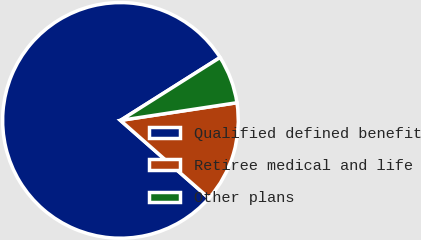Convert chart to OTSL. <chart><loc_0><loc_0><loc_500><loc_500><pie_chart><fcel>Qualified defined benefit<fcel>Retiree medical and life<fcel>Other plans<nl><fcel>79.56%<fcel>13.87%<fcel>6.57%<nl></chart> 